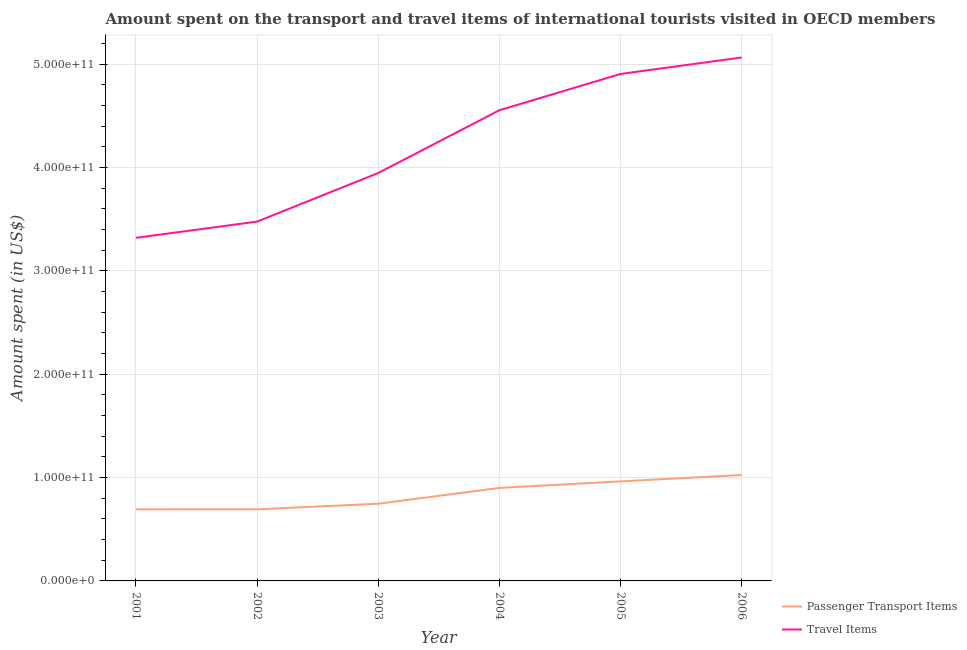Does the line corresponding to amount spent on passenger transport items intersect with the line corresponding to amount spent in travel items?
Give a very brief answer. No. What is the amount spent on passenger transport items in 2005?
Your answer should be compact. 9.63e+1. Across all years, what is the maximum amount spent in travel items?
Ensure brevity in your answer.  5.07e+11. Across all years, what is the minimum amount spent on passenger transport items?
Give a very brief answer. 6.93e+1. In which year was the amount spent on passenger transport items maximum?
Make the answer very short. 2006. What is the total amount spent on passenger transport items in the graph?
Offer a very short reply. 5.02e+11. What is the difference between the amount spent on passenger transport items in 2003 and that in 2004?
Offer a very short reply. -1.53e+1. What is the difference between the amount spent on passenger transport items in 2003 and the amount spent in travel items in 2004?
Offer a terse response. -3.81e+11. What is the average amount spent in travel items per year?
Make the answer very short. 4.21e+11. In the year 2005, what is the difference between the amount spent in travel items and amount spent on passenger transport items?
Provide a short and direct response. 3.94e+11. What is the ratio of the amount spent in travel items in 2005 to that in 2006?
Keep it short and to the point. 0.97. Is the difference between the amount spent in travel items in 2002 and 2006 greater than the difference between the amount spent on passenger transport items in 2002 and 2006?
Ensure brevity in your answer.  No. What is the difference between the highest and the second highest amount spent on passenger transport items?
Provide a short and direct response. 6.16e+09. What is the difference between the highest and the lowest amount spent on passenger transport items?
Offer a terse response. 3.32e+1. In how many years, is the amount spent in travel items greater than the average amount spent in travel items taken over all years?
Make the answer very short. 3. Is the sum of the amount spent in travel items in 2003 and 2005 greater than the maximum amount spent on passenger transport items across all years?
Offer a very short reply. Yes. Does the amount spent in travel items monotonically increase over the years?
Provide a succinct answer. Yes. Is the amount spent in travel items strictly greater than the amount spent on passenger transport items over the years?
Ensure brevity in your answer.  Yes. What is the difference between two consecutive major ticks on the Y-axis?
Offer a very short reply. 1.00e+11. Does the graph contain any zero values?
Offer a terse response. No. Where does the legend appear in the graph?
Keep it short and to the point. Bottom right. What is the title of the graph?
Your response must be concise. Amount spent on the transport and travel items of international tourists visited in OECD members. What is the label or title of the Y-axis?
Your answer should be very brief. Amount spent (in US$). What is the Amount spent (in US$) in Passenger Transport Items in 2001?
Keep it short and to the point. 6.93e+1. What is the Amount spent (in US$) in Travel Items in 2001?
Make the answer very short. 3.32e+11. What is the Amount spent (in US$) in Passenger Transport Items in 2002?
Your response must be concise. 6.93e+1. What is the Amount spent (in US$) of Travel Items in 2002?
Provide a short and direct response. 3.48e+11. What is the Amount spent (in US$) in Passenger Transport Items in 2003?
Give a very brief answer. 7.47e+1. What is the Amount spent (in US$) in Travel Items in 2003?
Give a very brief answer. 3.95e+11. What is the Amount spent (in US$) in Passenger Transport Items in 2004?
Your answer should be very brief. 9.00e+1. What is the Amount spent (in US$) in Travel Items in 2004?
Provide a succinct answer. 4.55e+11. What is the Amount spent (in US$) of Passenger Transport Items in 2005?
Ensure brevity in your answer.  9.63e+1. What is the Amount spent (in US$) of Travel Items in 2005?
Make the answer very short. 4.91e+11. What is the Amount spent (in US$) of Passenger Transport Items in 2006?
Keep it short and to the point. 1.02e+11. What is the Amount spent (in US$) in Travel Items in 2006?
Provide a short and direct response. 5.07e+11. Across all years, what is the maximum Amount spent (in US$) in Passenger Transport Items?
Your response must be concise. 1.02e+11. Across all years, what is the maximum Amount spent (in US$) of Travel Items?
Offer a very short reply. 5.07e+11. Across all years, what is the minimum Amount spent (in US$) of Passenger Transport Items?
Make the answer very short. 6.93e+1. Across all years, what is the minimum Amount spent (in US$) of Travel Items?
Provide a succinct answer. 3.32e+11. What is the total Amount spent (in US$) of Passenger Transport Items in the graph?
Ensure brevity in your answer.  5.02e+11. What is the total Amount spent (in US$) in Travel Items in the graph?
Offer a very short reply. 2.53e+12. What is the difference between the Amount spent (in US$) of Passenger Transport Items in 2001 and that in 2002?
Offer a very short reply. -2.66e+07. What is the difference between the Amount spent (in US$) in Travel Items in 2001 and that in 2002?
Your answer should be compact. -1.57e+1. What is the difference between the Amount spent (in US$) in Passenger Transport Items in 2001 and that in 2003?
Ensure brevity in your answer.  -5.44e+09. What is the difference between the Amount spent (in US$) of Travel Items in 2001 and that in 2003?
Offer a very short reply. -6.27e+1. What is the difference between the Amount spent (in US$) of Passenger Transport Items in 2001 and that in 2004?
Ensure brevity in your answer.  -2.07e+1. What is the difference between the Amount spent (in US$) in Travel Items in 2001 and that in 2004?
Provide a short and direct response. -1.23e+11. What is the difference between the Amount spent (in US$) in Passenger Transport Items in 2001 and that in 2005?
Your response must be concise. -2.71e+1. What is the difference between the Amount spent (in US$) of Travel Items in 2001 and that in 2005?
Make the answer very short. -1.59e+11. What is the difference between the Amount spent (in US$) in Passenger Transport Items in 2001 and that in 2006?
Your response must be concise. -3.32e+1. What is the difference between the Amount spent (in US$) in Travel Items in 2001 and that in 2006?
Your answer should be compact. -1.75e+11. What is the difference between the Amount spent (in US$) in Passenger Transport Items in 2002 and that in 2003?
Offer a very short reply. -5.41e+09. What is the difference between the Amount spent (in US$) of Travel Items in 2002 and that in 2003?
Your answer should be very brief. -4.70e+1. What is the difference between the Amount spent (in US$) in Passenger Transport Items in 2002 and that in 2004?
Offer a terse response. -2.07e+1. What is the difference between the Amount spent (in US$) of Travel Items in 2002 and that in 2004?
Your response must be concise. -1.08e+11. What is the difference between the Amount spent (in US$) in Passenger Transport Items in 2002 and that in 2005?
Provide a short and direct response. -2.70e+1. What is the difference between the Amount spent (in US$) in Travel Items in 2002 and that in 2005?
Provide a succinct answer. -1.43e+11. What is the difference between the Amount spent (in US$) of Passenger Transport Items in 2002 and that in 2006?
Your answer should be very brief. -3.32e+1. What is the difference between the Amount spent (in US$) in Travel Items in 2002 and that in 2006?
Make the answer very short. -1.59e+11. What is the difference between the Amount spent (in US$) in Passenger Transport Items in 2003 and that in 2004?
Keep it short and to the point. -1.53e+1. What is the difference between the Amount spent (in US$) of Travel Items in 2003 and that in 2004?
Keep it short and to the point. -6.07e+1. What is the difference between the Amount spent (in US$) in Passenger Transport Items in 2003 and that in 2005?
Offer a terse response. -2.16e+1. What is the difference between the Amount spent (in US$) in Travel Items in 2003 and that in 2005?
Make the answer very short. -9.59e+1. What is the difference between the Amount spent (in US$) in Passenger Transport Items in 2003 and that in 2006?
Provide a succinct answer. -2.78e+1. What is the difference between the Amount spent (in US$) in Travel Items in 2003 and that in 2006?
Keep it short and to the point. -1.12e+11. What is the difference between the Amount spent (in US$) of Passenger Transport Items in 2004 and that in 2005?
Make the answer very short. -6.32e+09. What is the difference between the Amount spent (in US$) of Travel Items in 2004 and that in 2005?
Your answer should be very brief. -3.51e+1. What is the difference between the Amount spent (in US$) in Passenger Transport Items in 2004 and that in 2006?
Offer a very short reply. -1.25e+1. What is the difference between the Amount spent (in US$) of Travel Items in 2004 and that in 2006?
Keep it short and to the point. -5.11e+1. What is the difference between the Amount spent (in US$) in Passenger Transport Items in 2005 and that in 2006?
Your response must be concise. -6.16e+09. What is the difference between the Amount spent (in US$) of Travel Items in 2005 and that in 2006?
Provide a succinct answer. -1.60e+1. What is the difference between the Amount spent (in US$) of Passenger Transport Items in 2001 and the Amount spent (in US$) of Travel Items in 2002?
Your response must be concise. -2.78e+11. What is the difference between the Amount spent (in US$) in Passenger Transport Items in 2001 and the Amount spent (in US$) in Travel Items in 2003?
Your answer should be compact. -3.25e+11. What is the difference between the Amount spent (in US$) of Passenger Transport Items in 2001 and the Amount spent (in US$) of Travel Items in 2004?
Ensure brevity in your answer.  -3.86e+11. What is the difference between the Amount spent (in US$) in Passenger Transport Items in 2001 and the Amount spent (in US$) in Travel Items in 2005?
Your answer should be very brief. -4.21e+11. What is the difference between the Amount spent (in US$) of Passenger Transport Items in 2001 and the Amount spent (in US$) of Travel Items in 2006?
Keep it short and to the point. -4.37e+11. What is the difference between the Amount spent (in US$) in Passenger Transport Items in 2002 and the Amount spent (in US$) in Travel Items in 2003?
Your answer should be compact. -3.25e+11. What is the difference between the Amount spent (in US$) in Passenger Transport Items in 2002 and the Amount spent (in US$) in Travel Items in 2004?
Provide a succinct answer. -3.86e+11. What is the difference between the Amount spent (in US$) of Passenger Transport Items in 2002 and the Amount spent (in US$) of Travel Items in 2005?
Your answer should be compact. -4.21e+11. What is the difference between the Amount spent (in US$) of Passenger Transport Items in 2002 and the Amount spent (in US$) of Travel Items in 2006?
Your answer should be very brief. -4.37e+11. What is the difference between the Amount spent (in US$) in Passenger Transport Items in 2003 and the Amount spent (in US$) in Travel Items in 2004?
Give a very brief answer. -3.81e+11. What is the difference between the Amount spent (in US$) in Passenger Transport Items in 2003 and the Amount spent (in US$) in Travel Items in 2005?
Offer a terse response. -4.16e+11. What is the difference between the Amount spent (in US$) in Passenger Transport Items in 2003 and the Amount spent (in US$) in Travel Items in 2006?
Ensure brevity in your answer.  -4.32e+11. What is the difference between the Amount spent (in US$) in Passenger Transport Items in 2004 and the Amount spent (in US$) in Travel Items in 2005?
Provide a short and direct response. -4.01e+11. What is the difference between the Amount spent (in US$) in Passenger Transport Items in 2004 and the Amount spent (in US$) in Travel Items in 2006?
Provide a succinct answer. -4.17e+11. What is the difference between the Amount spent (in US$) of Passenger Transport Items in 2005 and the Amount spent (in US$) of Travel Items in 2006?
Offer a very short reply. -4.10e+11. What is the average Amount spent (in US$) in Passenger Transport Items per year?
Give a very brief answer. 8.37e+1. What is the average Amount spent (in US$) in Travel Items per year?
Make the answer very short. 4.21e+11. In the year 2001, what is the difference between the Amount spent (in US$) of Passenger Transport Items and Amount spent (in US$) of Travel Items?
Provide a short and direct response. -2.63e+11. In the year 2002, what is the difference between the Amount spent (in US$) in Passenger Transport Items and Amount spent (in US$) in Travel Items?
Offer a terse response. -2.78e+11. In the year 2003, what is the difference between the Amount spent (in US$) in Passenger Transport Items and Amount spent (in US$) in Travel Items?
Offer a terse response. -3.20e+11. In the year 2004, what is the difference between the Amount spent (in US$) in Passenger Transport Items and Amount spent (in US$) in Travel Items?
Your answer should be compact. -3.65e+11. In the year 2005, what is the difference between the Amount spent (in US$) in Passenger Transport Items and Amount spent (in US$) in Travel Items?
Give a very brief answer. -3.94e+11. In the year 2006, what is the difference between the Amount spent (in US$) in Passenger Transport Items and Amount spent (in US$) in Travel Items?
Your response must be concise. -4.04e+11. What is the ratio of the Amount spent (in US$) in Travel Items in 2001 to that in 2002?
Offer a terse response. 0.95. What is the ratio of the Amount spent (in US$) of Passenger Transport Items in 2001 to that in 2003?
Your response must be concise. 0.93. What is the ratio of the Amount spent (in US$) of Travel Items in 2001 to that in 2003?
Provide a succinct answer. 0.84. What is the ratio of the Amount spent (in US$) of Passenger Transport Items in 2001 to that in 2004?
Ensure brevity in your answer.  0.77. What is the ratio of the Amount spent (in US$) in Travel Items in 2001 to that in 2004?
Make the answer very short. 0.73. What is the ratio of the Amount spent (in US$) of Passenger Transport Items in 2001 to that in 2005?
Your answer should be very brief. 0.72. What is the ratio of the Amount spent (in US$) of Travel Items in 2001 to that in 2005?
Keep it short and to the point. 0.68. What is the ratio of the Amount spent (in US$) of Passenger Transport Items in 2001 to that in 2006?
Make the answer very short. 0.68. What is the ratio of the Amount spent (in US$) in Travel Items in 2001 to that in 2006?
Your answer should be very brief. 0.66. What is the ratio of the Amount spent (in US$) of Passenger Transport Items in 2002 to that in 2003?
Your answer should be compact. 0.93. What is the ratio of the Amount spent (in US$) of Travel Items in 2002 to that in 2003?
Provide a succinct answer. 0.88. What is the ratio of the Amount spent (in US$) of Passenger Transport Items in 2002 to that in 2004?
Give a very brief answer. 0.77. What is the ratio of the Amount spent (in US$) in Travel Items in 2002 to that in 2004?
Give a very brief answer. 0.76. What is the ratio of the Amount spent (in US$) of Passenger Transport Items in 2002 to that in 2005?
Ensure brevity in your answer.  0.72. What is the ratio of the Amount spent (in US$) of Travel Items in 2002 to that in 2005?
Make the answer very short. 0.71. What is the ratio of the Amount spent (in US$) in Passenger Transport Items in 2002 to that in 2006?
Your response must be concise. 0.68. What is the ratio of the Amount spent (in US$) of Travel Items in 2002 to that in 2006?
Make the answer very short. 0.69. What is the ratio of the Amount spent (in US$) of Passenger Transport Items in 2003 to that in 2004?
Give a very brief answer. 0.83. What is the ratio of the Amount spent (in US$) in Travel Items in 2003 to that in 2004?
Your response must be concise. 0.87. What is the ratio of the Amount spent (in US$) of Passenger Transport Items in 2003 to that in 2005?
Make the answer very short. 0.78. What is the ratio of the Amount spent (in US$) in Travel Items in 2003 to that in 2005?
Offer a very short reply. 0.8. What is the ratio of the Amount spent (in US$) in Passenger Transport Items in 2003 to that in 2006?
Provide a succinct answer. 0.73. What is the ratio of the Amount spent (in US$) of Travel Items in 2003 to that in 2006?
Make the answer very short. 0.78. What is the ratio of the Amount spent (in US$) in Passenger Transport Items in 2004 to that in 2005?
Ensure brevity in your answer.  0.93. What is the ratio of the Amount spent (in US$) of Travel Items in 2004 to that in 2005?
Make the answer very short. 0.93. What is the ratio of the Amount spent (in US$) in Passenger Transport Items in 2004 to that in 2006?
Provide a short and direct response. 0.88. What is the ratio of the Amount spent (in US$) of Travel Items in 2004 to that in 2006?
Your answer should be very brief. 0.9. What is the ratio of the Amount spent (in US$) of Passenger Transport Items in 2005 to that in 2006?
Provide a short and direct response. 0.94. What is the ratio of the Amount spent (in US$) of Travel Items in 2005 to that in 2006?
Provide a short and direct response. 0.97. What is the difference between the highest and the second highest Amount spent (in US$) in Passenger Transport Items?
Keep it short and to the point. 6.16e+09. What is the difference between the highest and the second highest Amount spent (in US$) in Travel Items?
Offer a very short reply. 1.60e+1. What is the difference between the highest and the lowest Amount spent (in US$) in Passenger Transport Items?
Provide a short and direct response. 3.32e+1. What is the difference between the highest and the lowest Amount spent (in US$) of Travel Items?
Your answer should be very brief. 1.75e+11. 